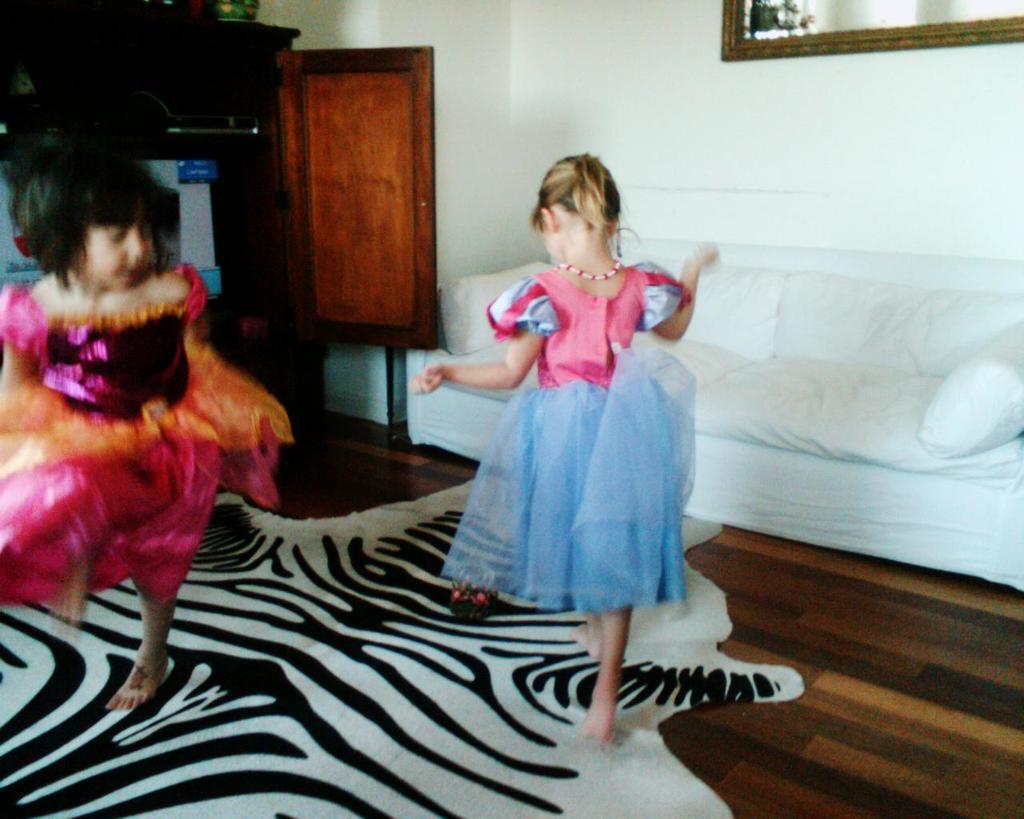Could you give a brief overview of what you see in this image? In this image there are two girls dancing on the floor. In the background there is a white color sofa and also a frame attached to the wall. Wooden door is also visible. 